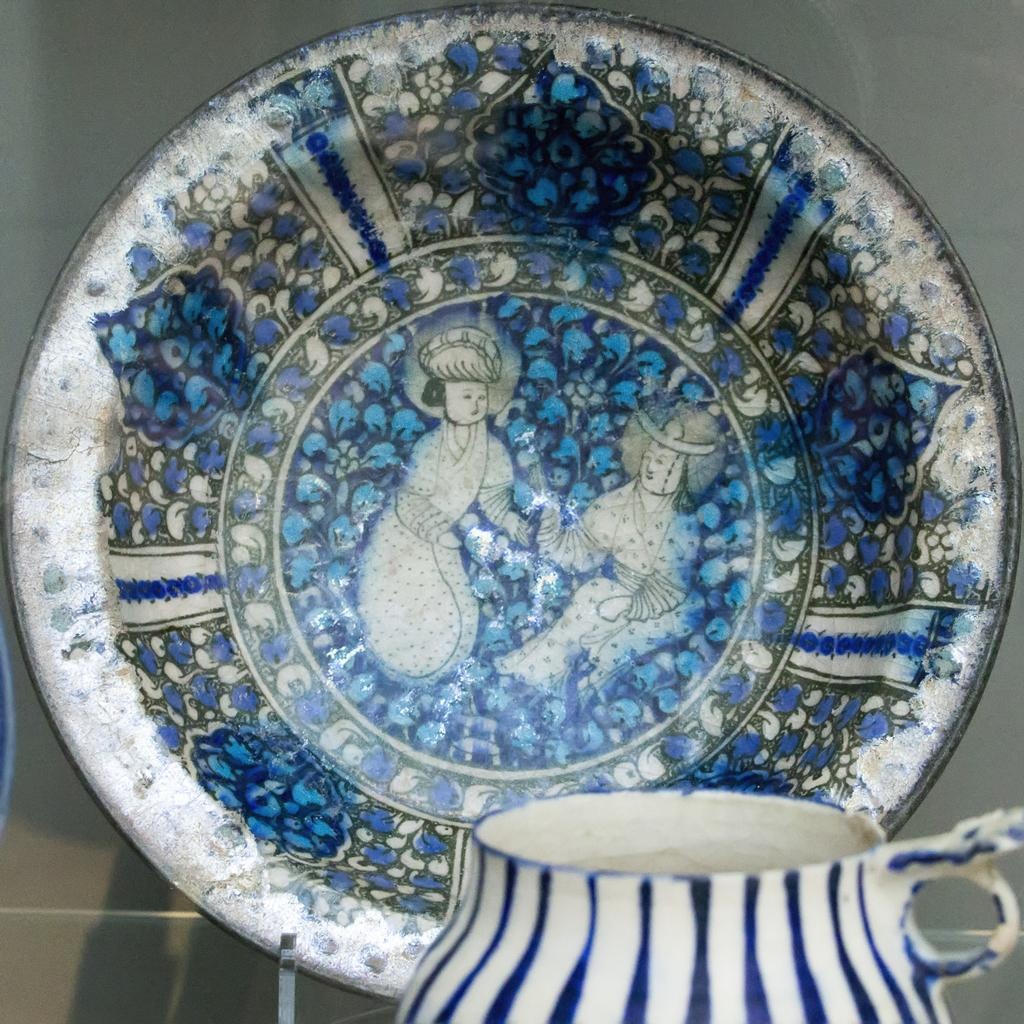What is present on the plate in the image? The provided facts do not mention any specific items on the plate. What can be said about the colors of the plate and cup in the image? The plate and cup are both white and blue in color. How are the plate and cup arranged in the image? The cup is in front of the plate. What type of playground equipment can be seen in the image? There is no playground equipment present in the image; it features a plate and cup. What decision is being made by the plate and cup in the image? The plate and cup are inanimate objects and cannot make decisions. 